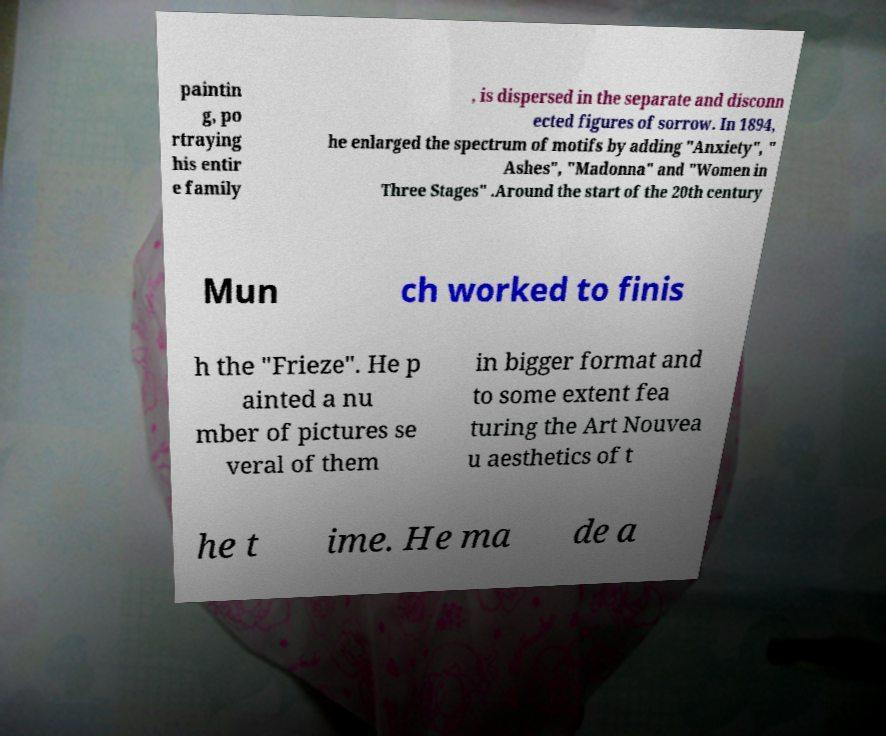I need the written content from this picture converted into text. Can you do that? paintin g, po rtraying his entir e family , is dispersed in the separate and disconn ected figures of sorrow. In 1894, he enlarged the spectrum of motifs by adding "Anxiety", " Ashes", "Madonna" and "Women in Three Stages" .Around the start of the 20th century Mun ch worked to finis h the "Frieze". He p ainted a nu mber of pictures se veral of them in bigger format and to some extent fea turing the Art Nouvea u aesthetics of t he t ime. He ma de a 